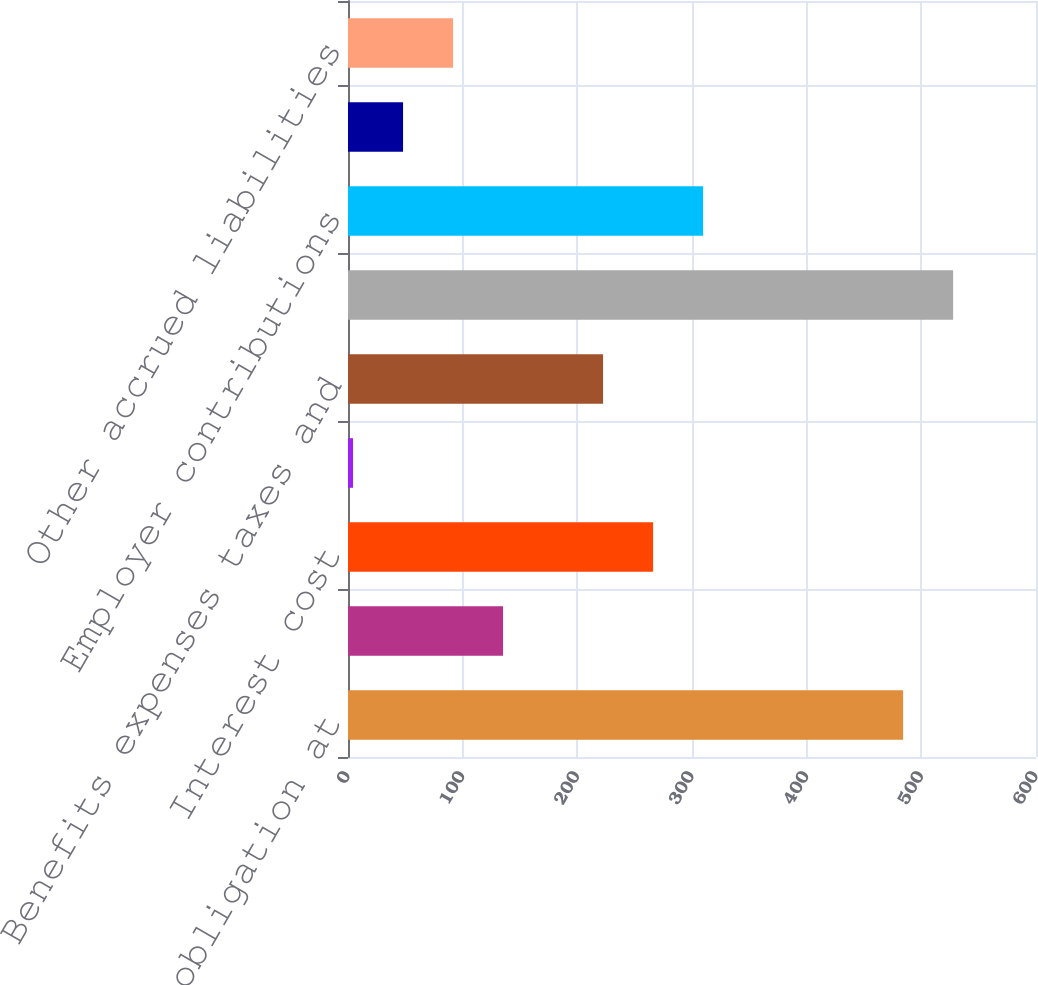Convert chart. <chart><loc_0><loc_0><loc_500><loc_500><bar_chart><fcel>Benefit obligation at<fcel>Service cost<fcel>Interest cost<fcel>Actuarial loss (gain)<fcel>Benefits expenses taxes and<fcel>Benefit obligation at end of<fcel>Employer contributions<fcel>Funded status<fcel>Other accrued liabilities<nl><fcel>484.11<fcel>135.23<fcel>266.06<fcel>4.4<fcel>222.45<fcel>527.72<fcel>309.67<fcel>48.01<fcel>91.62<nl></chart> 